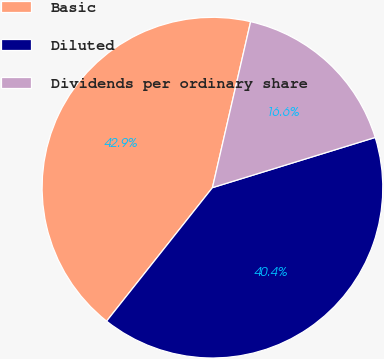Convert chart. <chart><loc_0><loc_0><loc_500><loc_500><pie_chart><fcel>Basic<fcel>Diluted<fcel>Dividends per ordinary share<nl><fcel>42.93%<fcel>40.43%<fcel>16.64%<nl></chart> 